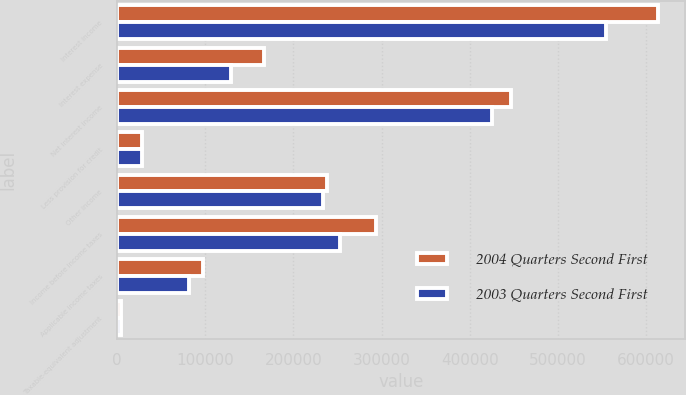Convert chart to OTSL. <chart><loc_0><loc_0><loc_500><loc_500><stacked_bar_chart><ecel><fcel>Interest income<fcel>Interest expense<fcel>Net interest income<fcel>Less provision for credit<fcel>Other income<fcel>Income before income taxes<fcel>Applicable income taxes<fcel>Taxable-equivalent adjustment<nl><fcel>2004 Quarters Second First<fcel>613012<fcel>166755<fcel>446257<fcel>28000<fcel>237559<fcel>293894<fcel>97624<fcel>4065<nl><fcel>2003 Quarters Second First<fcel>554673<fcel>129173<fcel>425500<fcel>28000<fcel>233757<fcel>252902<fcel>81801<fcel>4200<nl></chart> 